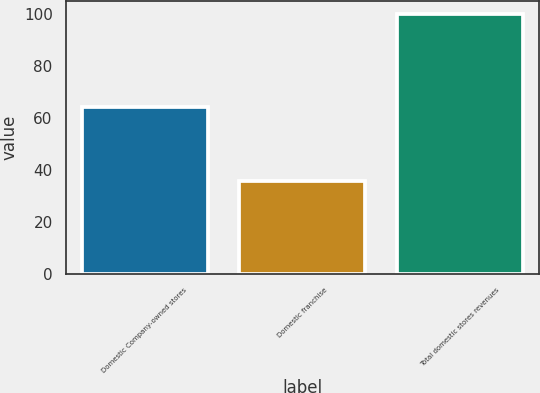Convert chart. <chart><loc_0><loc_0><loc_500><loc_500><bar_chart><fcel>Domestic Company-owned stores<fcel>Domestic franchise<fcel>Total domestic stores revenues<nl><fcel>64.3<fcel>35.7<fcel>100<nl></chart> 